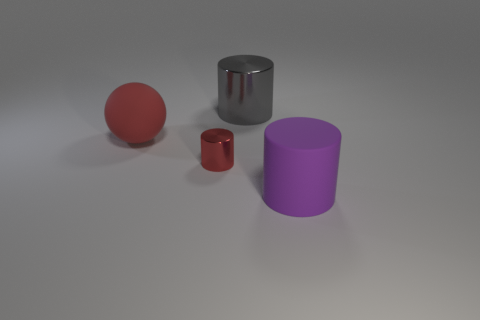How does the lighting affect the mood or perception of the image? The lighting in the image is soft and diffuse, creating gentle shadows which give the scene a calm and neutral mood. There are no harsh highlights or deep shadows, which contributes to a sense of simplicity and clarity. This type of lighting is often used to ensure that the colors and shapes of objects are clearly visible without dramatic visual contrasts, which can be helpful for accurately observing and analyzing the items' properties. 